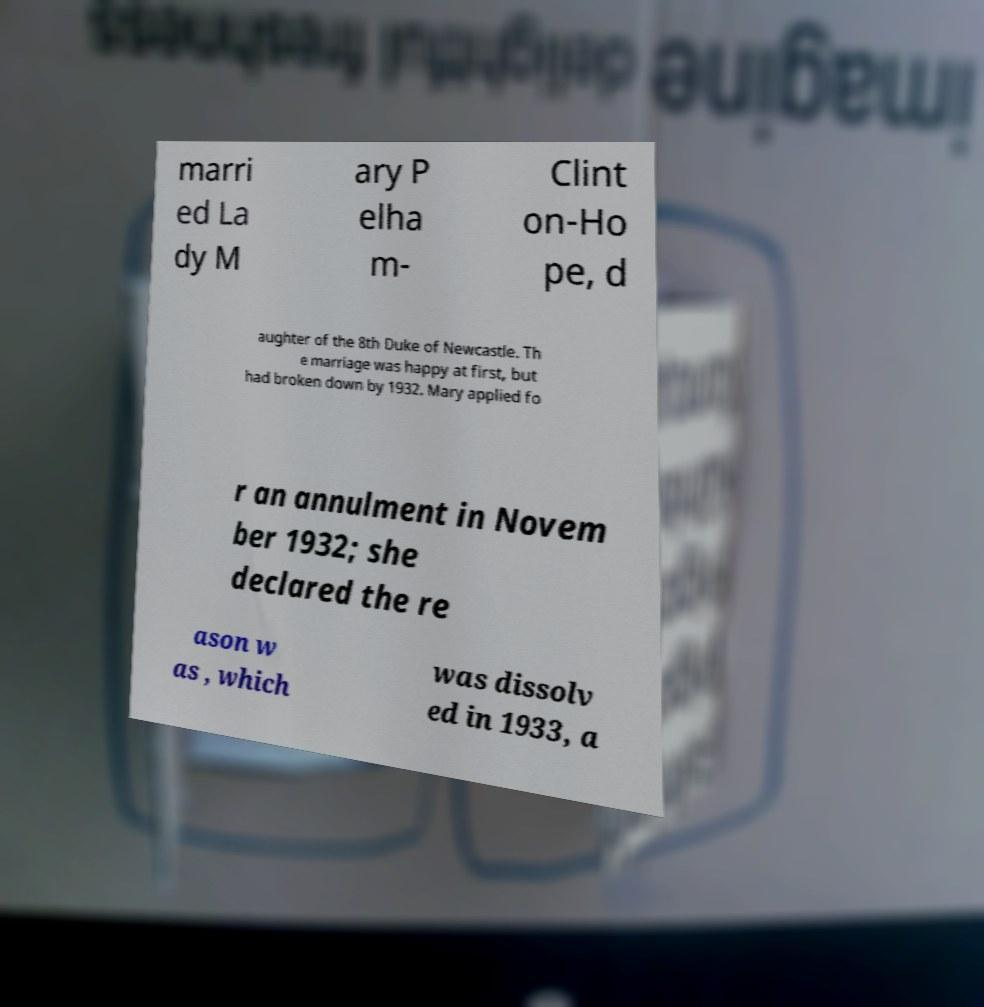What messages or text are displayed in this image? I need them in a readable, typed format. marri ed La dy M ary P elha m- Clint on-Ho pe, d aughter of the 8th Duke of Newcastle. Th e marriage was happy at first, but had broken down by 1932. Mary applied fo r an annulment in Novem ber 1932; she declared the re ason w as , which was dissolv ed in 1933, a 